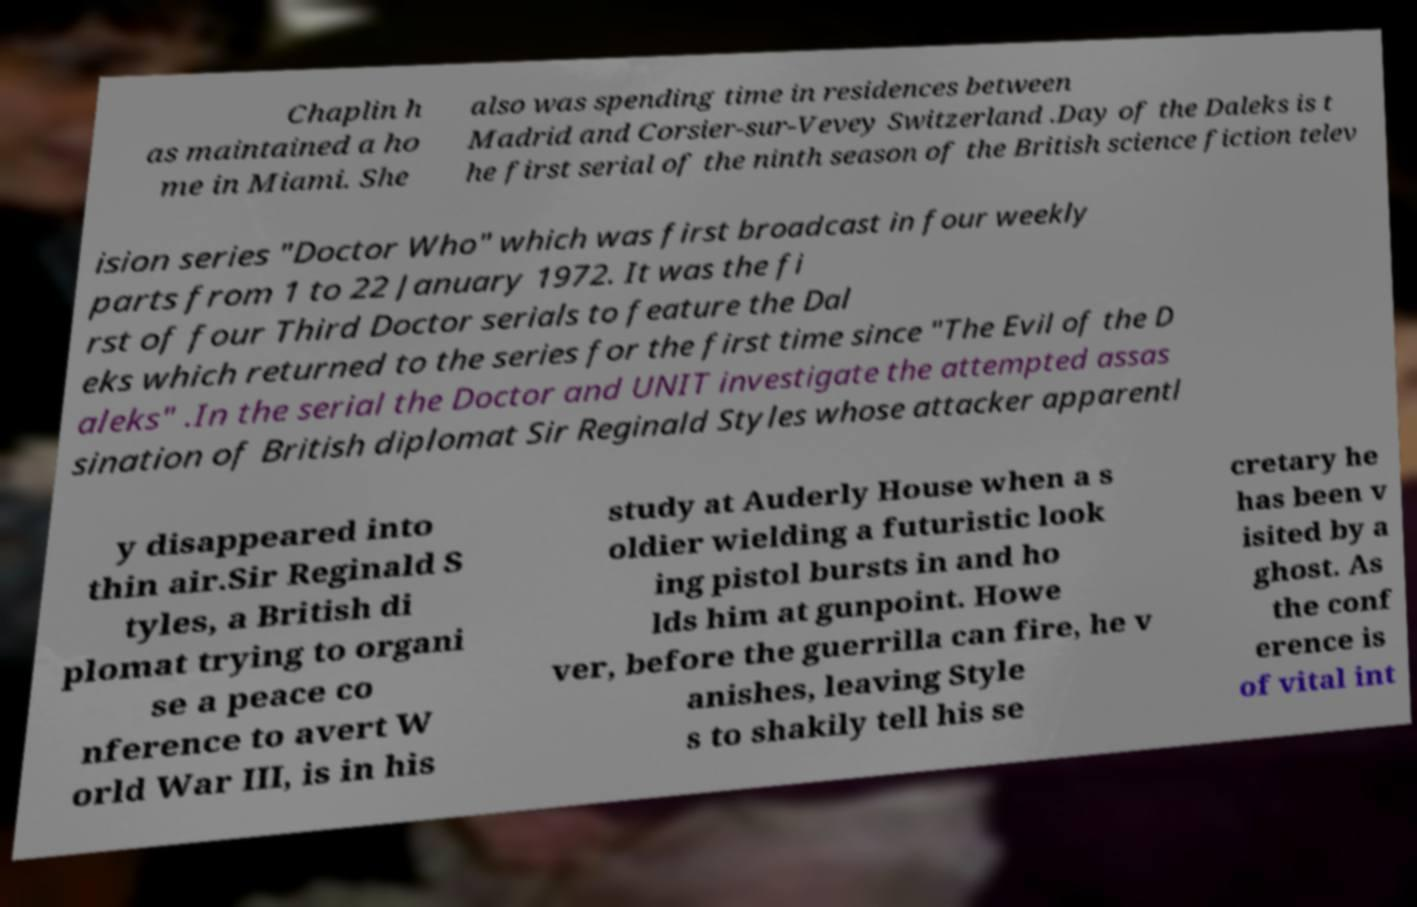Can you accurately transcribe the text from the provided image for me? Chaplin h as maintained a ho me in Miami. She also was spending time in residences between Madrid and Corsier-sur-Vevey Switzerland .Day of the Daleks is t he first serial of the ninth season of the British science fiction telev ision series "Doctor Who" which was first broadcast in four weekly parts from 1 to 22 January 1972. It was the fi rst of four Third Doctor serials to feature the Dal eks which returned to the series for the first time since "The Evil of the D aleks" .In the serial the Doctor and UNIT investigate the attempted assas sination of British diplomat Sir Reginald Styles whose attacker apparentl y disappeared into thin air.Sir Reginald S tyles, a British di plomat trying to organi se a peace co nference to avert W orld War III, is in his study at Auderly House when a s oldier wielding a futuristic look ing pistol bursts in and ho lds him at gunpoint. Howe ver, before the guerrilla can fire, he v anishes, leaving Style s to shakily tell his se cretary he has been v isited by a ghost. As the conf erence is of vital int 